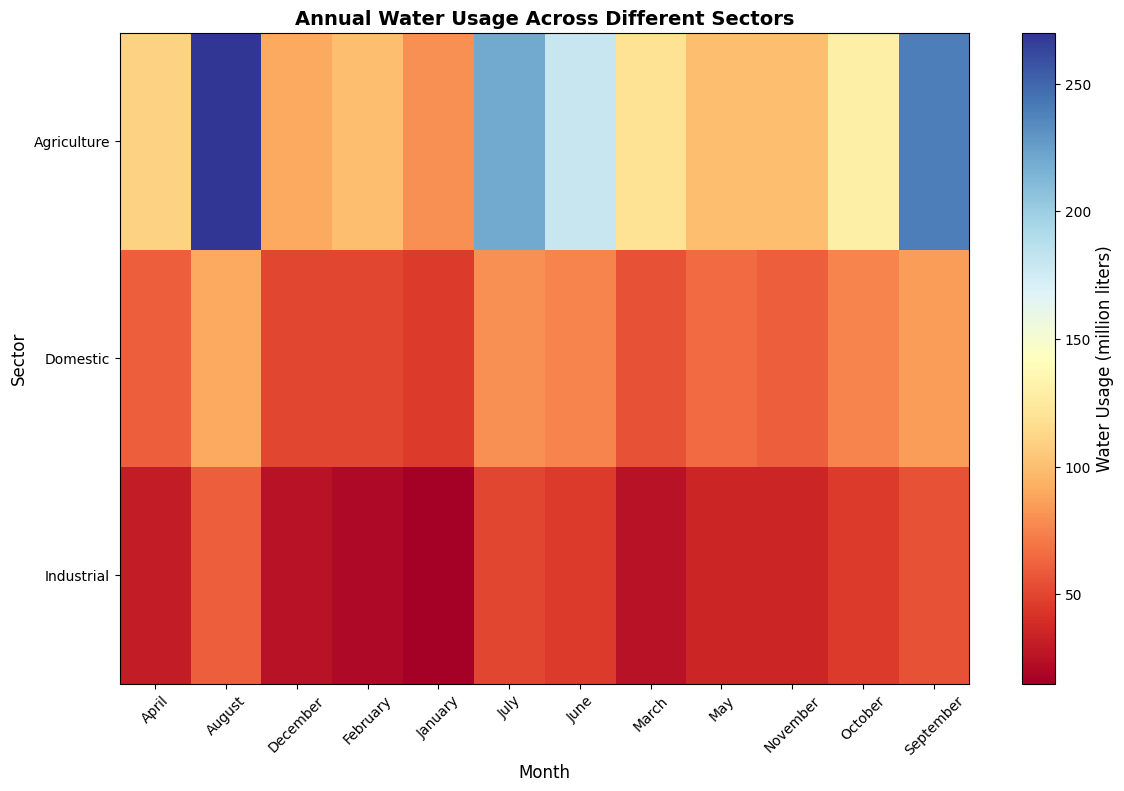Which month has the highest water usage in the agriculture sector? To find the month with the highest water usage in the agriculture sector, look at the row labeled 'Agriculture' and identify the cell with the deepest blue color, indicating the highest usage. The month with the darkest shade should correspond to the highest water usage.
Answer: August How does water usage in the domestic sector for June compare to that in the industrial sector for the same month? Compare the cells in the 'Domestic' and 'Industrial' rows under the month of June. The cell in the 'Domestic' row should be a lighter shade if it has lower water usage compared to the 'Industrial' sector.
Answer: Domestic sector has more water usage than Industrial in June What is the difference in water usage between the agriculture sector in April and June? Find the cells corresponding to April and June in the 'Agriculture' row. Note the water usage values for both months and subtract the April value from the June value.
Answer: 70 million liters What is the average water usage for the industrial sector across all months? To find the average water usage for the industrial sector, look at all the cells in the 'Industrial' row, sum their values and then divide by the number of months (12).
Answer: 39.58 million liters Which sector shows the highest water usage in August? Look at the cells under the month of August for all three sectors (Agriculture, Domestic, Industrial). The cell with the deepest blue indicates the highest water usage.
Answer: Agriculture Does the domestic sector ever surpass the agriculture sector in monthly water usage? Compare the monthly usage for 'Domestic' and 'Agriculture' sectors across all months. Check for any month where the 'Domestic' cell is a darker shade of blue than the 'Agriculture' cell.
Answer: No What are the two months with the most significant difference in water usage for the agriculture sector? Identify the two months for 'Agriculture' with the lightest and darkest shades of blue, indicating the lowest and highest usage, respectively. Subtract the value of the lighter cell from the darker cell.
Answer: August and January What is the trend in water usage for the industrial sector from January to December? Examine the shades of blue from January to December in the 'Industrial' row. Describe the progression: does the color get progressively deeper, indicating increasing usage, or lighter, indicating decreasing usage?
Answer: Increasing generally By how much does water usage in the domestic sector increase from January to July? Compare the values in the 'Domestic' row for January and July. Subtract the January value from the July value.
Answer: 35 million liters Among all sectors, which specific month shows the lowest water usage? Look across all months for each sector. The cell with the lightest shade of blue indicates the lowest water usage.
Answer: January, Industrial 